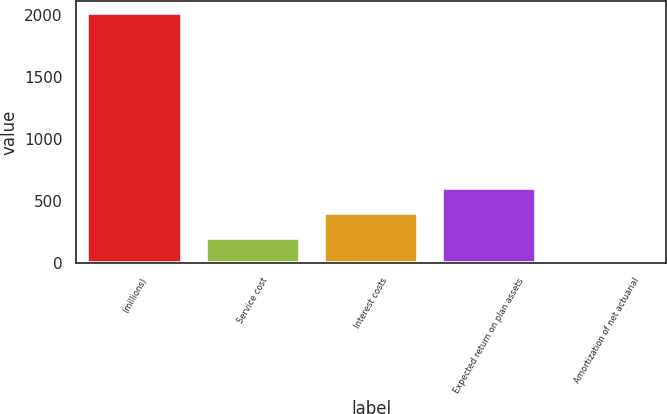Convert chart. <chart><loc_0><loc_0><loc_500><loc_500><bar_chart><fcel>(millions)<fcel>Service cost<fcel>Interest costs<fcel>Expected return on plan assets<fcel>Amortization of net actuarial<nl><fcel>2017<fcel>205.39<fcel>406.68<fcel>607.97<fcel>4.1<nl></chart> 